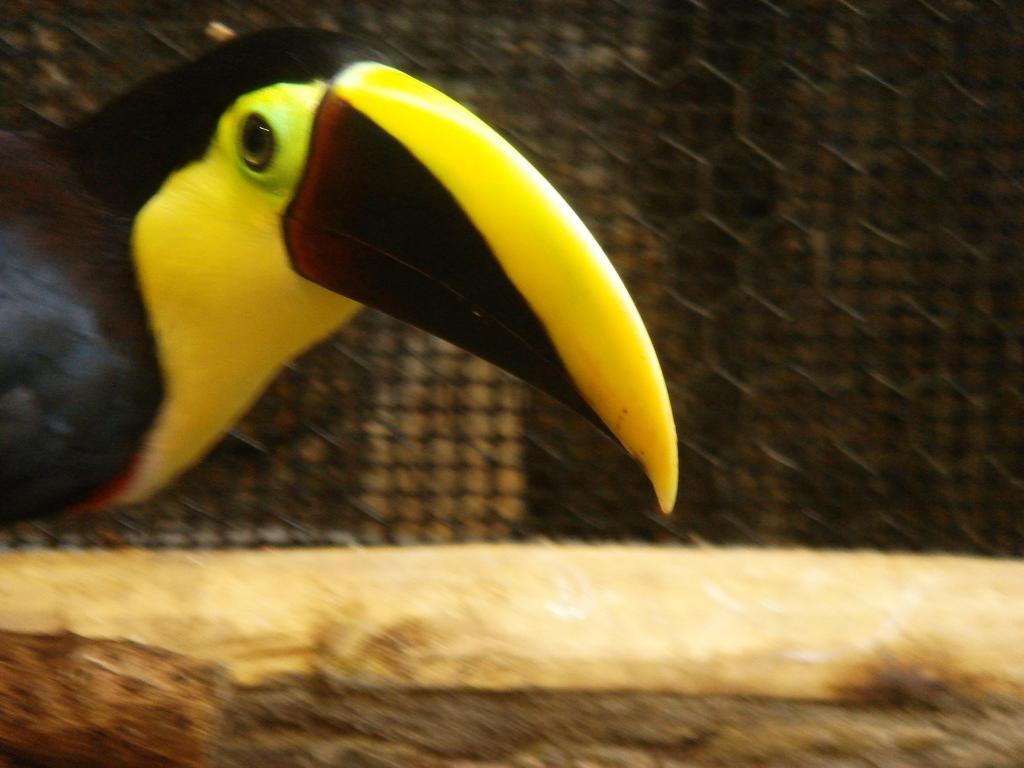What is located on the left side of the image? There is a bird on the left side of the image. Which direction is the bird facing? The bird is facing towards the right side. What can be seen in the background of the image? There is a net fencing in the background of the image. What is at the bottom of the image? There is a wall at the bottom of the image. How far away is the bird from the wall in the image? The distance between the bird and the wall cannot be determined from the image alone, as there is no reference point for scale. 